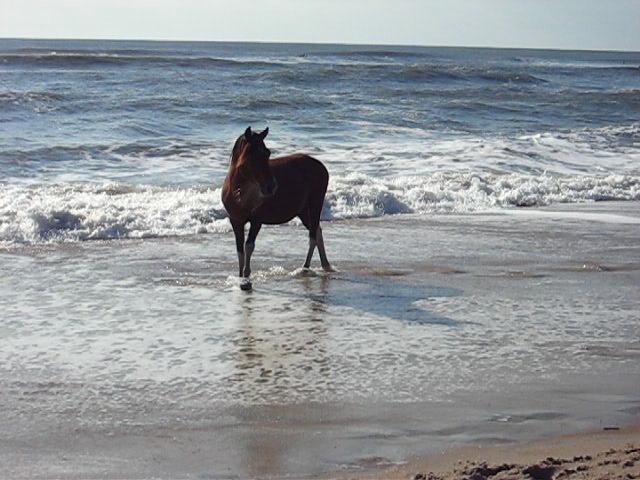How many animals are standing in the water?
Give a very brief answer. 1. How many orange cups are on the table?
Give a very brief answer. 0. 